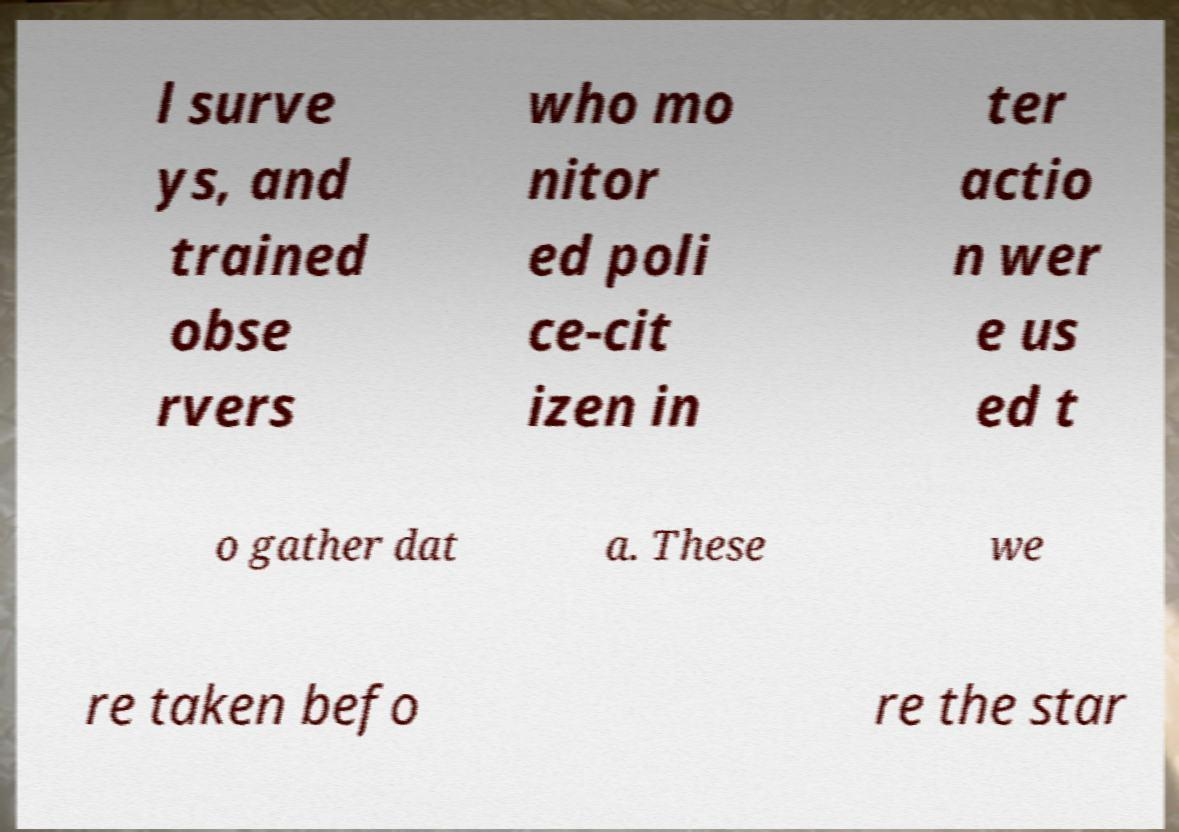For documentation purposes, I need the text within this image transcribed. Could you provide that? l surve ys, and trained obse rvers who mo nitor ed poli ce-cit izen in ter actio n wer e us ed t o gather dat a. These we re taken befo re the star 